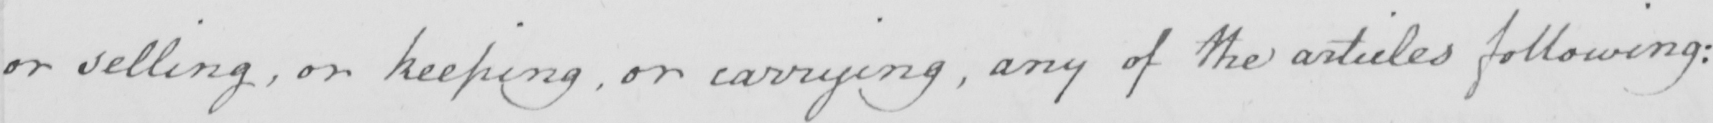What does this handwritten line say? or selling , or keeping , or carrying , any of the articles following ; 